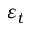Convert formula to latex. <formula><loc_0><loc_0><loc_500><loc_500>\varepsilon _ { t }</formula> 